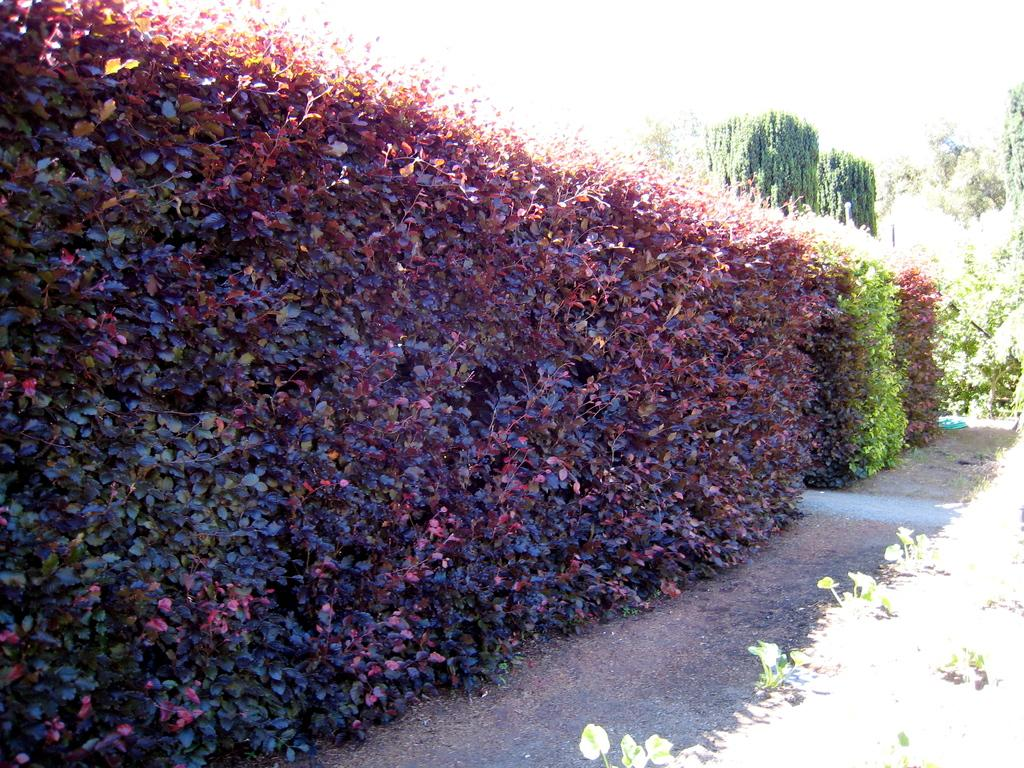What type of vegetation can be seen in the image? There are bushes, trees, and plants in the image. What part of the natural environment is visible in the image? The sky is visible in the image. What type of bloodstain can be seen on the flag in the image? There is no flag or bloodstain present in the image. 